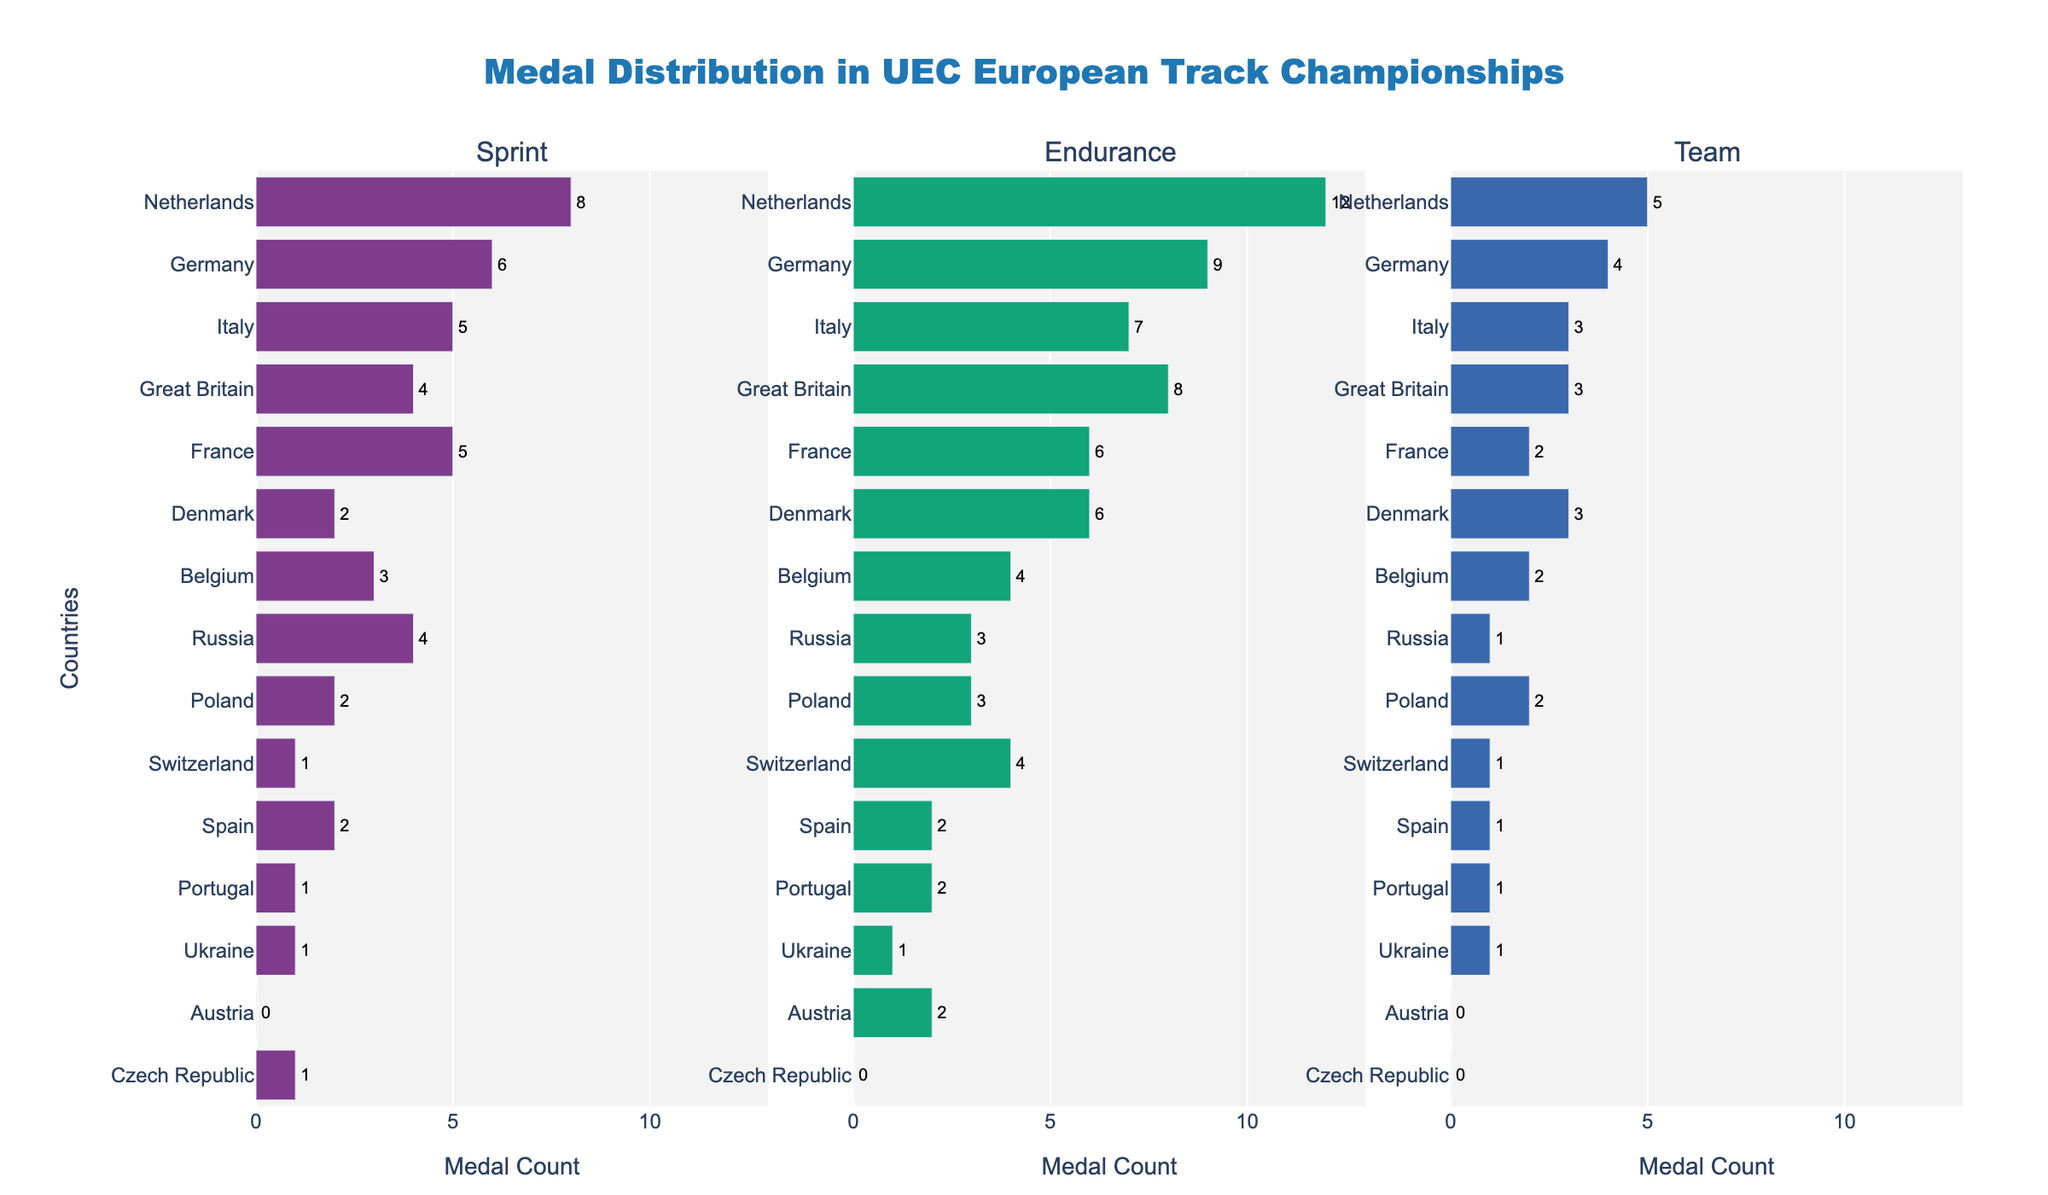What's the title of the figure? The title of the figure is displayed prominently at the top and reads "Medal Distribution in UEC European Track Championships".
Answer: Medal Distribution in UEC European Track Championships Which country has the highest total medal count? By summing the medals across all event types, the country with the highest total is identified. Netherlands has the highest total with 25 medals.
Answer: Netherlands How many medals has Germany won in the Endurance events? The bar representing Germany in the Endurance subplot shows the number of medals they have won. The text label indicates that Germany has won 9 medals in Endurance events.
Answer: 9 Compare the number of Sprint medals won by Belgium and Spain. Which country has more? By looking at the bar lengths or text labels in the Sprint subplot, Belgium has 3 Sprint medals while Spain has 2. Hence, Belgium has more Sprint medals.
Answer: Belgium What is the combined total of medals won by France and Denmark in the Team events? Add the number of Team medals for France (2) and Denmark (3) from the Team subplot. The combined total is 2 + 3 = 5.
Answer: 5 Which country has the lowest number of Endurance medals? By comparing all the bars in the Endurance subplot, Czech Republic has the lowest number with 0 medals.
Answer: Czech Republic What is the range of Sprint medals among all countries? The highest number of Sprint medals is 8 (Netherlands) and the lowest is 0 (Austria), so the range is 8 - 0 = 8.
Answer: 8 How many countries have won at least 1 medal in each event type? Count the number of countries that have at least 1 medal in Sprint, Endurance, and Team subplots. Netherlands, Germany, Italy, Great Britain, France, Belgium, Poland, and Ukraine have at least 1 medal in each type.
Answer: 8 Which country has more total medals: Italy or Great Britain? Compare the total medals for Italy (15) and Great Britain (15) from the respective text labels. Both countries have the same total medals count.
Answer: Both have 15 What is the average number of Team medals among the top 3 countries by total medals? The top 3 countries by total medals are Netherlands, Germany, and Italy. Their Team medals are 5, 4, and 3 respectively. The average is (5 + 4 + 3) / 3 = 4.
Answer: 4 